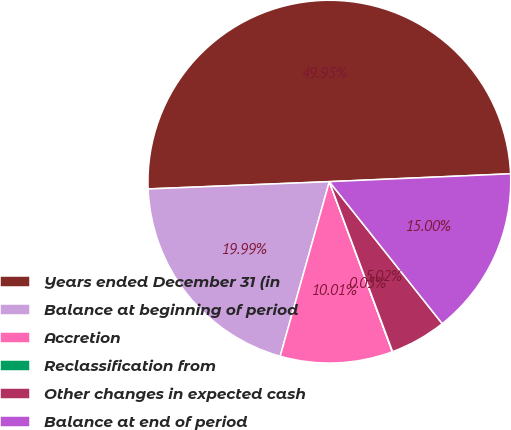Convert chart to OTSL. <chart><loc_0><loc_0><loc_500><loc_500><pie_chart><fcel>Years ended December 31 (in<fcel>Balance at beginning of period<fcel>Accretion<fcel>Reclassification from<fcel>Other changes in expected cash<fcel>Balance at end of period<nl><fcel>49.95%<fcel>19.99%<fcel>10.01%<fcel>0.03%<fcel>5.02%<fcel>15.0%<nl></chart> 